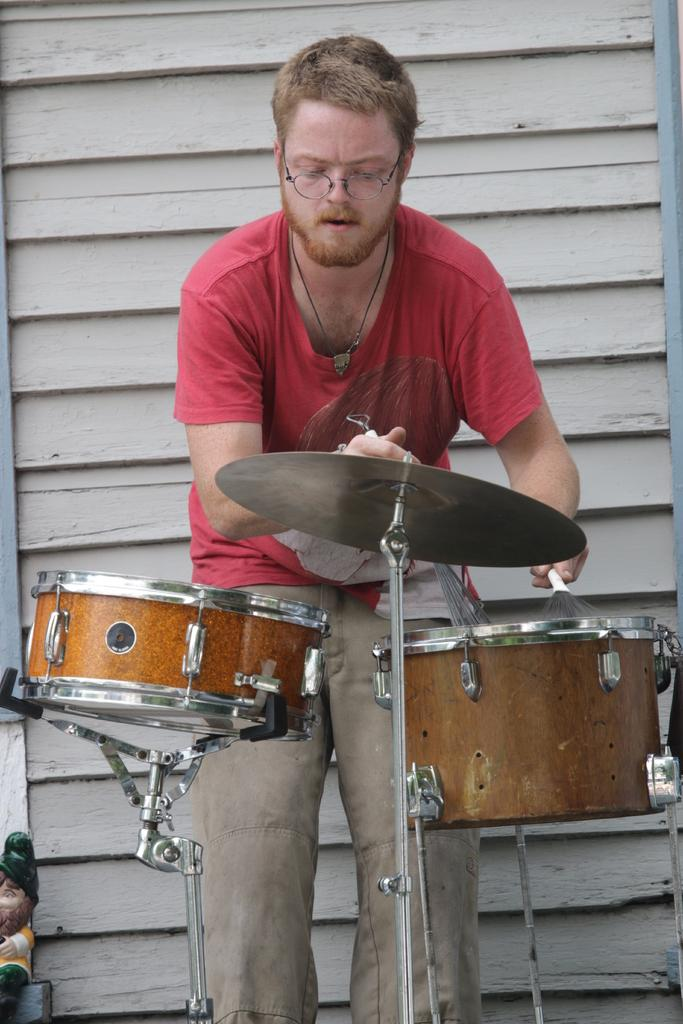Who is the main subject in the image? There is a person in the image. What is the person doing in the image? The person is playing musical drums. Can you describe the person's position in the image? The person is standing. How many dolls are present in the image? There are no dolls present in the image; the main subject is a person playing musical drums. 